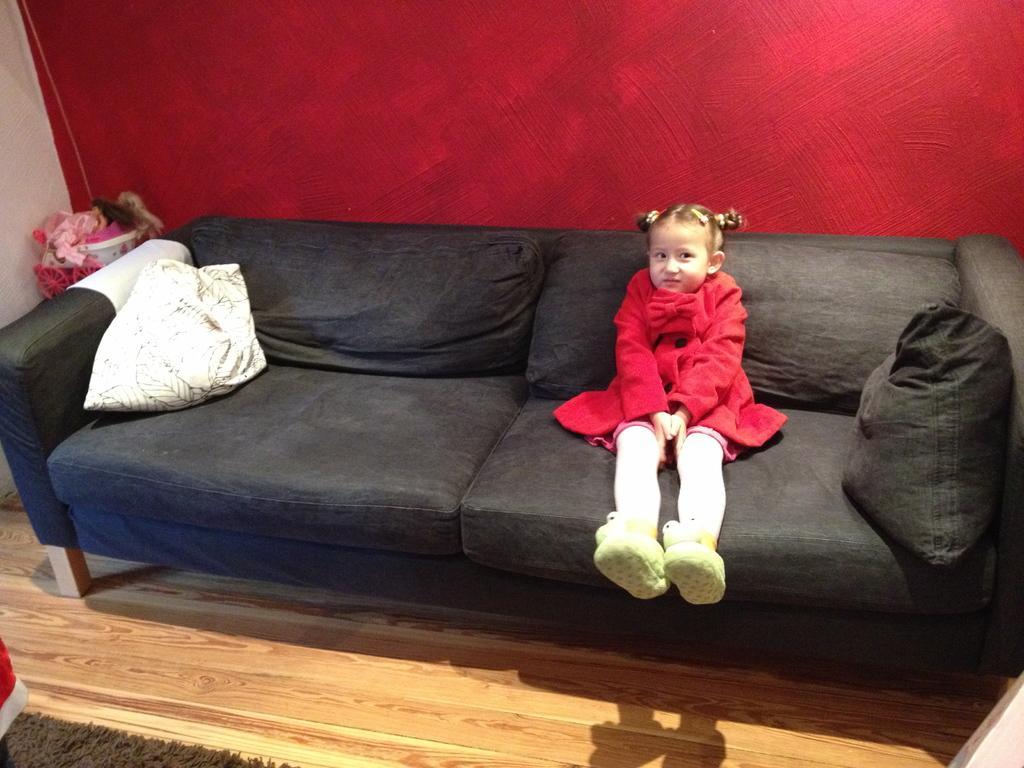Could you give a brief overview of what you see in this image? This picture shows a girl sitting in the sofa. The sofa is in black color and there are some pillows here. In the background, there is a red colored wall here. 